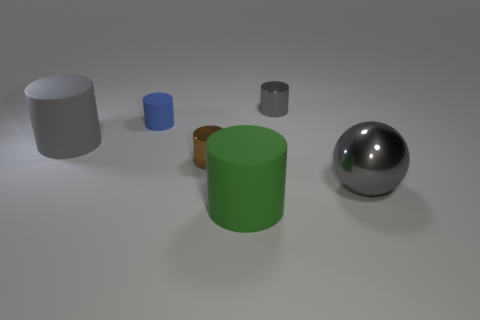Do the large gray rubber object and the small brown thing have the same shape?
Offer a terse response. Yes. There is a tiny brown thing that is the same shape as the green thing; what is its material?
Offer a very short reply. Metal. Is there any other thing of the same color as the big shiny sphere?
Give a very brief answer. Yes. The matte object that is the same color as the big shiny object is what shape?
Your answer should be very brief. Cylinder. Are there any other things that are the same shape as the tiny brown shiny object?
Provide a succinct answer. Yes. What number of other objects are there of the same size as the gray shiny cylinder?
Provide a short and direct response. 2. Is the size of the gray metal thing in front of the big gray cylinder the same as the rubber cylinder that is on the left side of the tiny blue rubber cylinder?
Your response must be concise. Yes. What number of objects are large gray metallic objects or objects behind the large green object?
Your answer should be very brief. 5. There is a thing that is behind the tiny blue object; what size is it?
Provide a short and direct response. Small. Are there fewer objects that are left of the big metal ball than green rubber things in front of the tiny brown cylinder?
Offer a very short reply. No. 